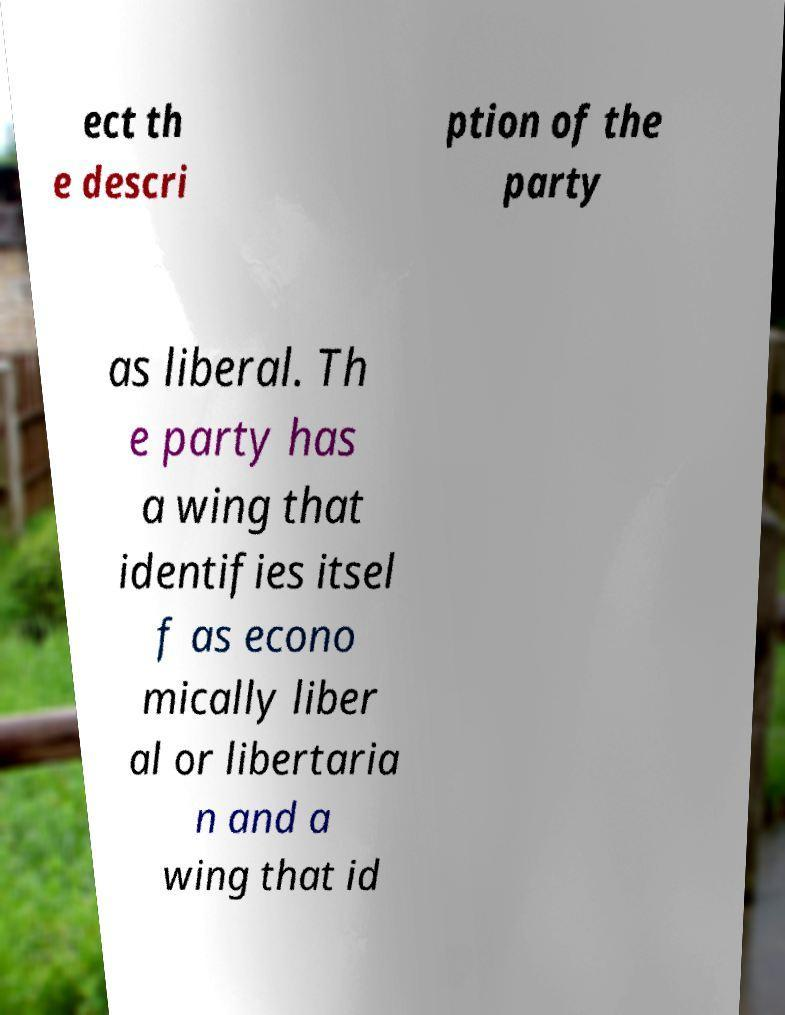What messages or text are displayed in this image? I need them in a readable, typed format. ect th e descri ption of the party as liberal. Th e party has a wing that identifies itsel f as econo mically liber al or libertaria n and a wing that id 